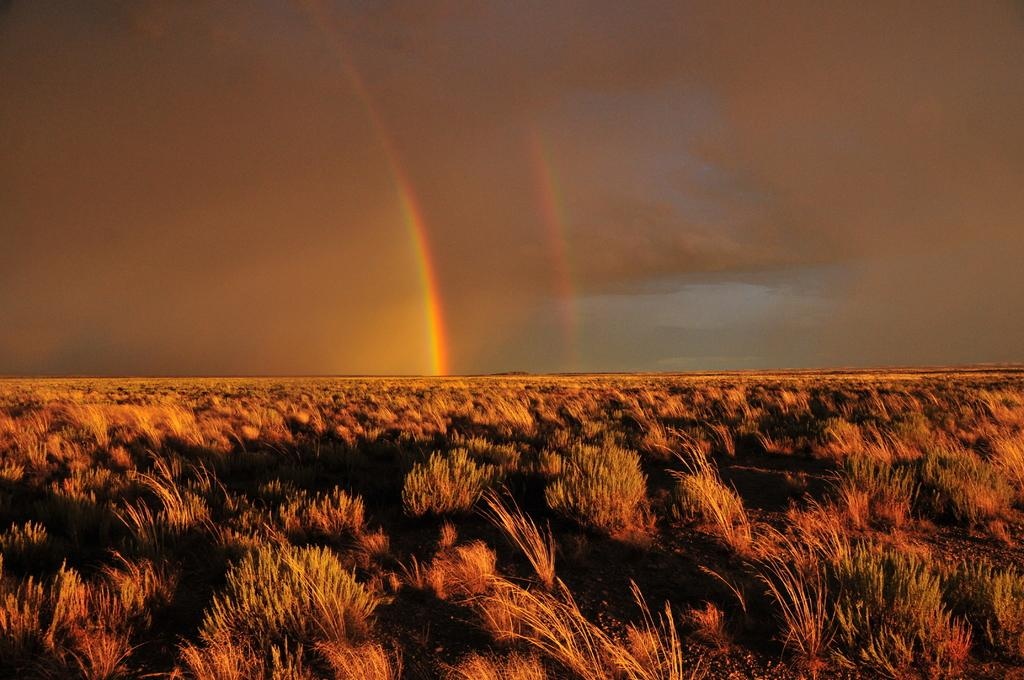What type of vegetation is present on the ground in the image? There is grass on the ground. What can be seen in the sky in the image? There are clouds and a rainbow visible in the sky. What language is the frog speaking in the image? There is no frog present in the image, so it is not possible to determine what language it might be speaking. 